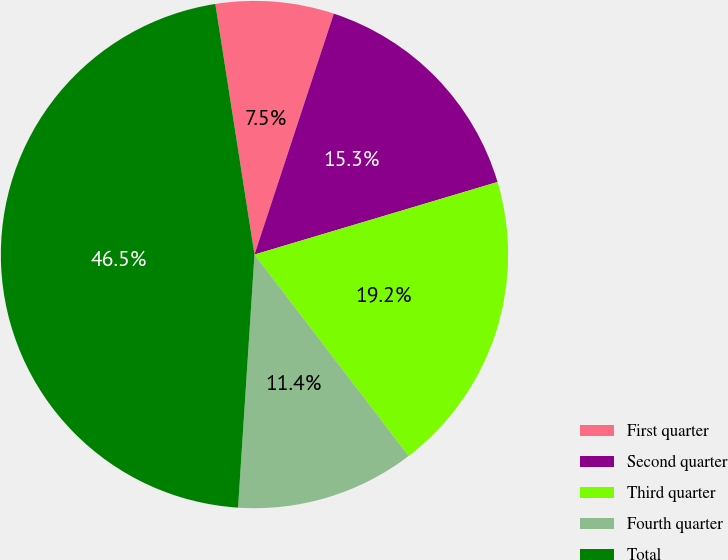Convert chart. <chart><loc_0><loc_0><loc_500><loc_500><pie_chart><fcel>First quarter<fcel>Second quarter<fcel>Third quarter<fcel>Fourth quarter<fcel>Total<nl><fcel>7.53%<fcel>15.32%<fcel>19.22%<fcel>11.43%<fcel>46.5%<nl></chart> 